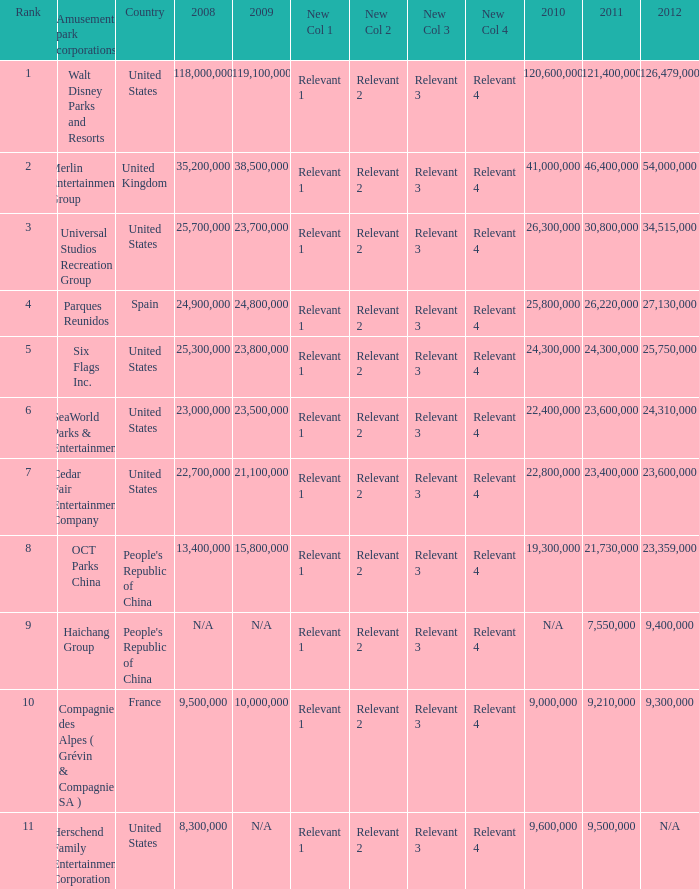What is the Rank listed for the attendance of 2010 of 9,000,000 and 2011 larger than 9,210,000? None. 